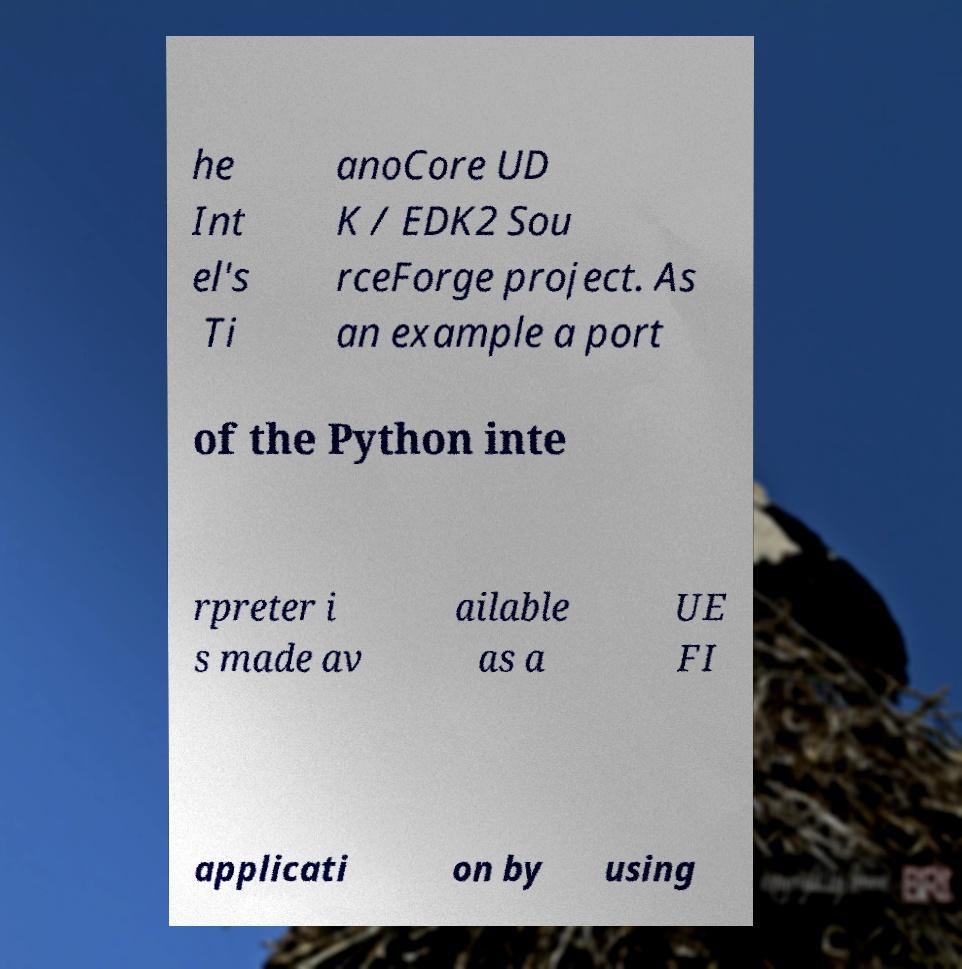Can you accurately transcribe the text from the provided image for me? he Int el's Ti anoCore UD K / EDK2 Sou rceForge project. As an example a port of the Python inte rpreter i s made av ailable as a UE FI applicati on by using 